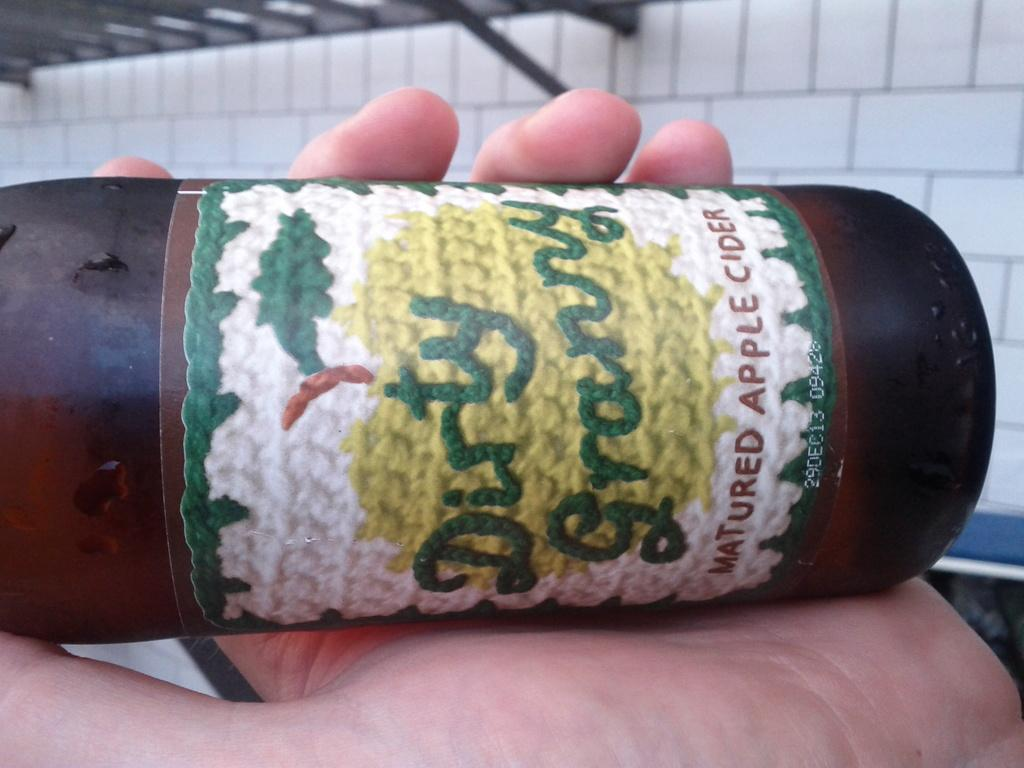<image>
Create a compact narrative representing the image presented. a bottle being held by someone labeled 'dirty granny matured apple cider' 